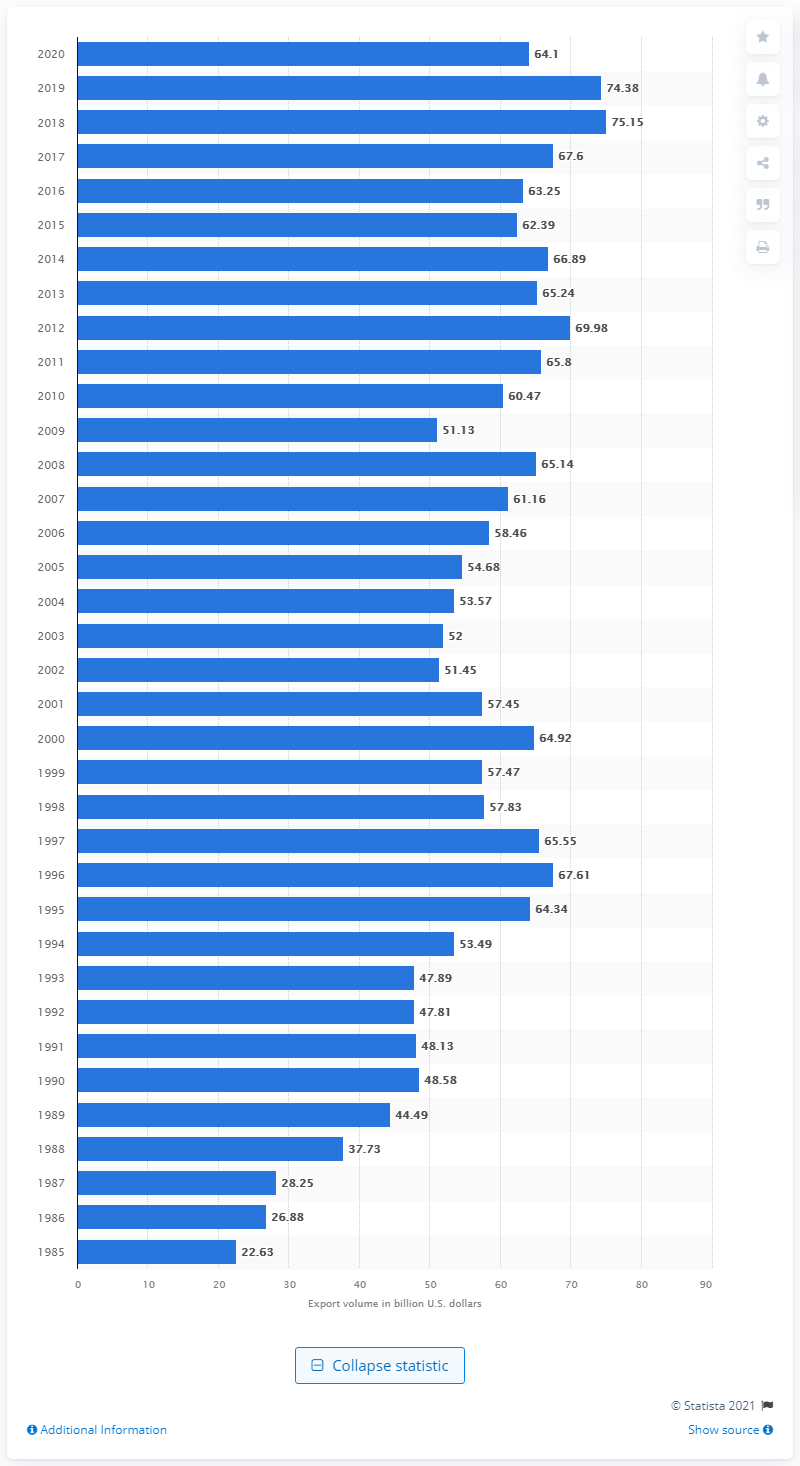Identify some key points in this picture. In 2020, the United States exported 64.1 billion dollars to Japan. 